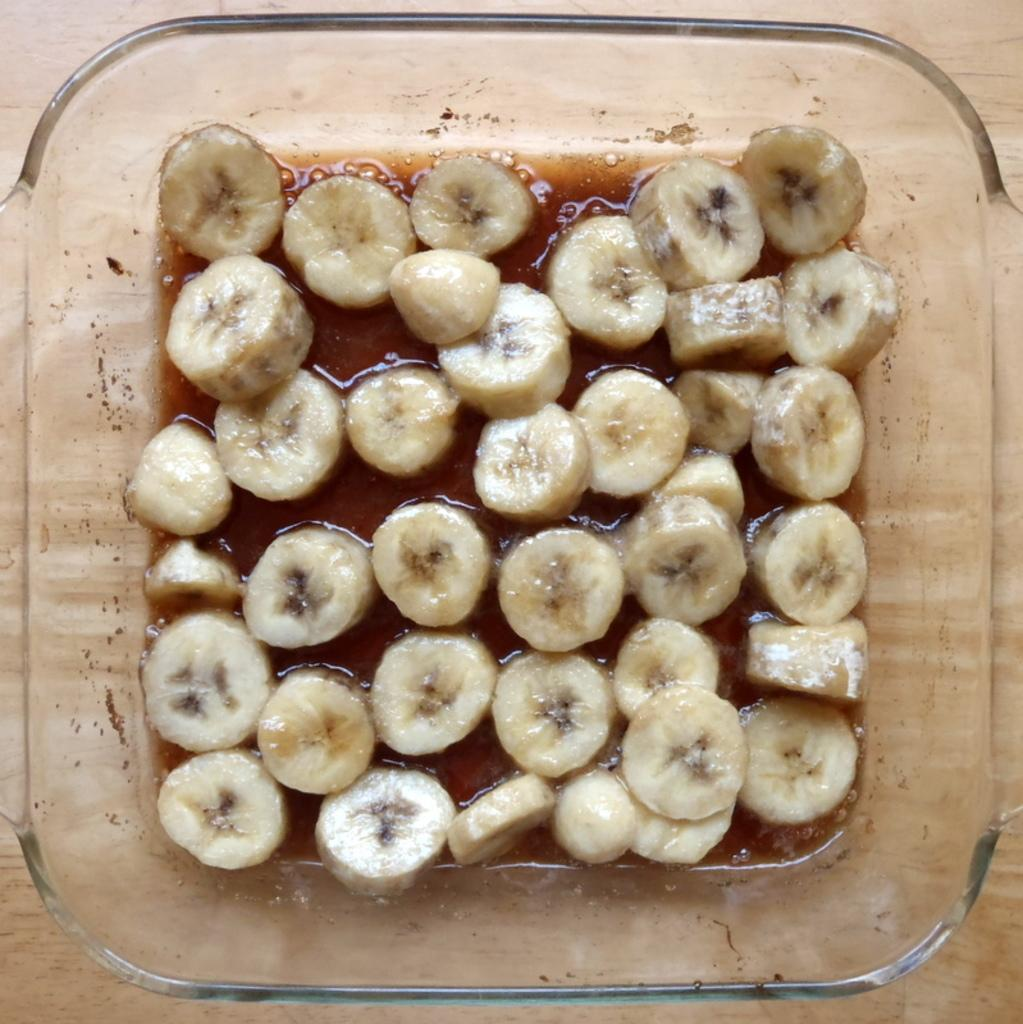What type of fruit can be seen in the image? There are bananas in the image. What else can be seen besides the bananas? There are other food items in the image. How are the food items contained in the image? The food items are in a glass bowl. What is the surface beneath the glass bowl? The glass bowl is on a wooden surface. What health benefits can be gained from walking on the sidewalk in the image? There is no sidewalk present in the image, and walking on a sidewalk is not related to the health benefits of the food items shown. 